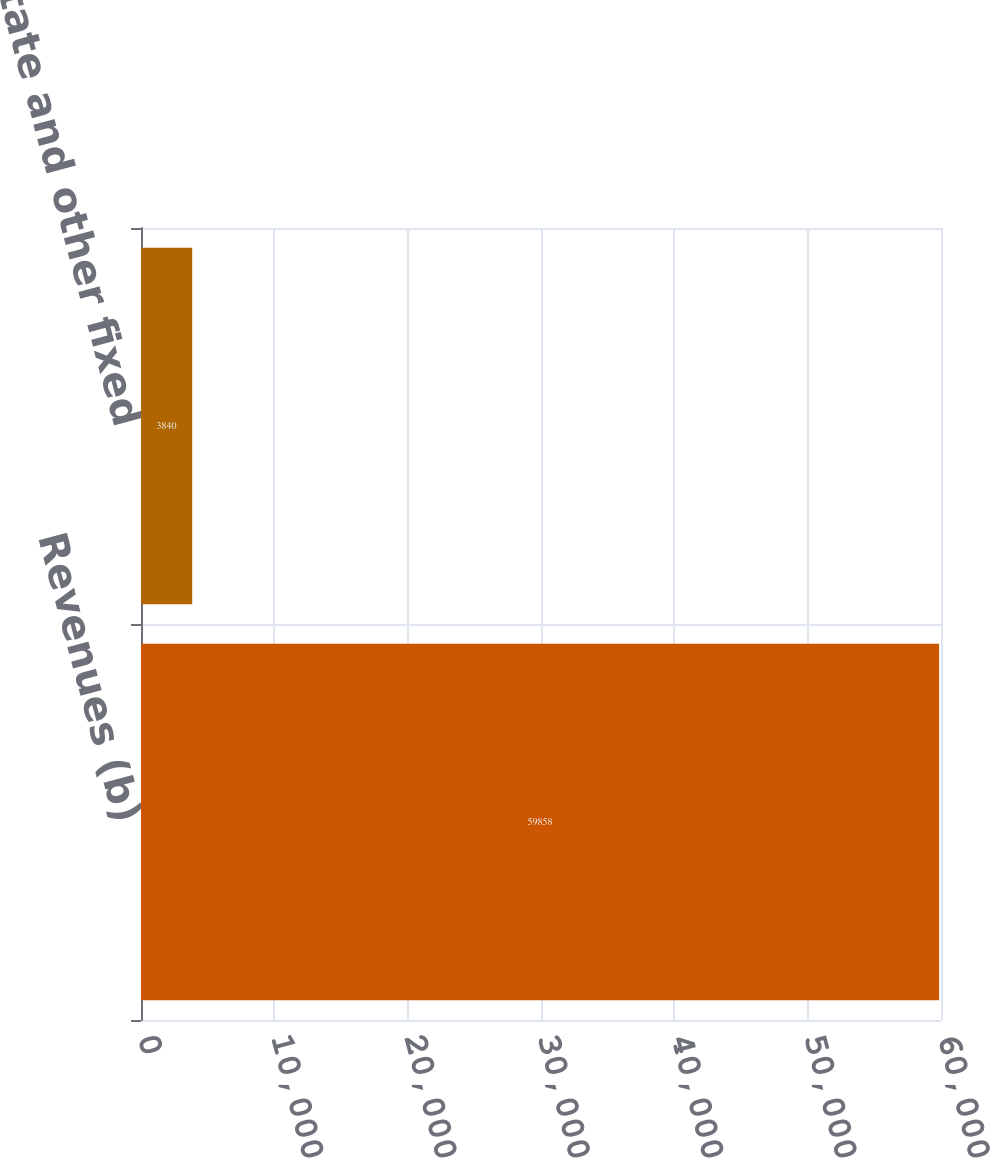<chart> <loc_0><loc_0><loc_500><loc_500><bar_chart><fcel>Revenues (b)<fcel>Real estate and other fixed<nl><fcel>59858<fcel>3840<nl></chart> 